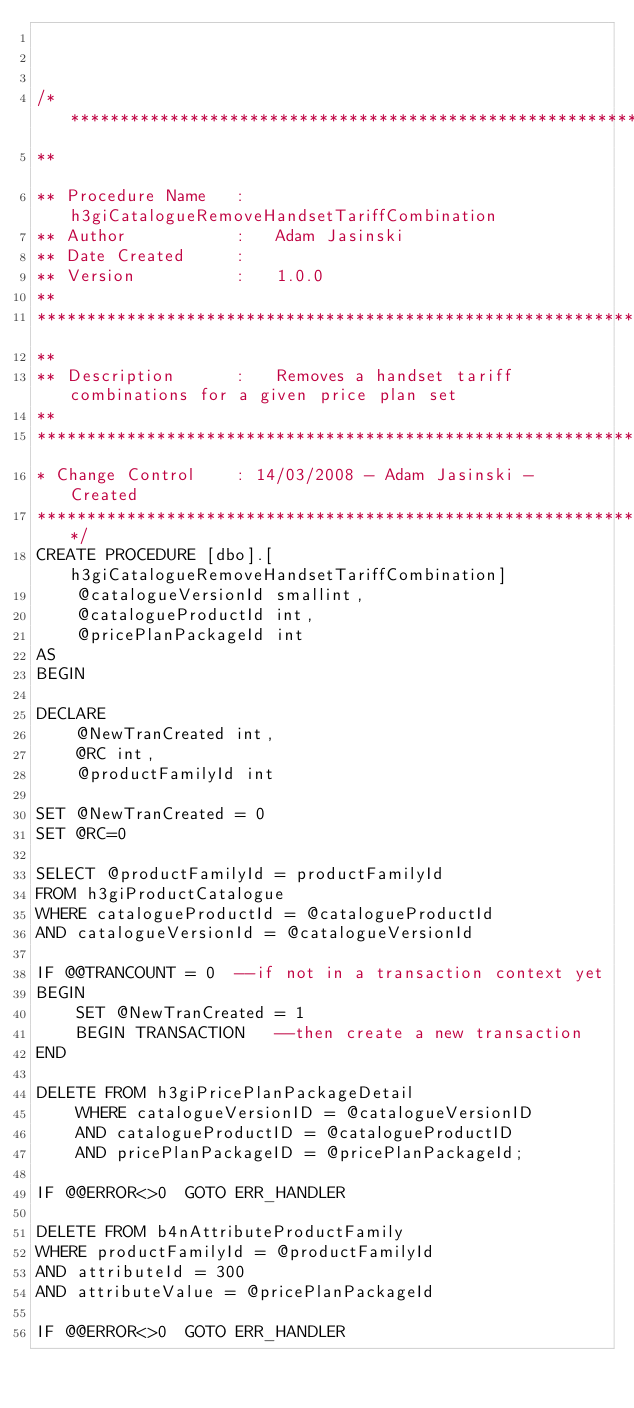Convert code to text. <code><loc_0><loc_0><loc_500><loc_500><_SQL_>


/*********************************************************************************************************************
**																					
** Procedure Name	:	h3giCatalogueRemoveHandsetTariffCombination
** Author			:	Adam Jasinski
** Date Created		:	
** Version			:	1.0.0
**					
**********************************************************************************************************************
**				
** Description		:	Removes a handset tariff combinations for a given price plan set
**					
**********************************************************************************************************************
* Change Control	: 14/03/2008 - Adam Jasinski - Created
**********************************************************************************************************************/
CREATE PROCEDURE [dbo].[h3giCatalogueRemoveHandsetTariffCombination]
	@catalogueVersionId smallint, 
	@catalogueProductId int,
	@pricePlanPackageId int
AS
BEGIN

DECLARE 
	@NewTranCreated int,
	@RC int,
	@productFamilyId int
	
SET @NewTranCreated = 0
SET @RC=0

SELECT @productFamilyId = productFamilyId
FROM h3giProductCatalogue
WHERE catalogueProductId = @catalogueProductId
AND catalogueVersionId = @catalogueVersionId

IF @@TRANCOUNT = 0 	--if not in a transaction context yet
BEGIN
	SET @NewTranCreated = 1
	BEGIN TRANSACTION 	--then create a new transaction
END

DELETE FROM h3giPricePlanPackageDetail
	WHERE catalogueVersionID = @catalogueVersionID
	AND catalogueProductID = @catalogueProductID
	AND pricePlanPackageID = @pricePlanPackageId;

IF @@ERROR<>0  GOTO ERR_HANDLER

DELETE FROM b4nAttributeProductFamily
WHERE productFamilyId = @productFamilyId
AND attributeId = 300
AND attributeValue = @pricePlanPackageId

IF @@ERROR<>0  GOTO ERR_HANDLER</code> 